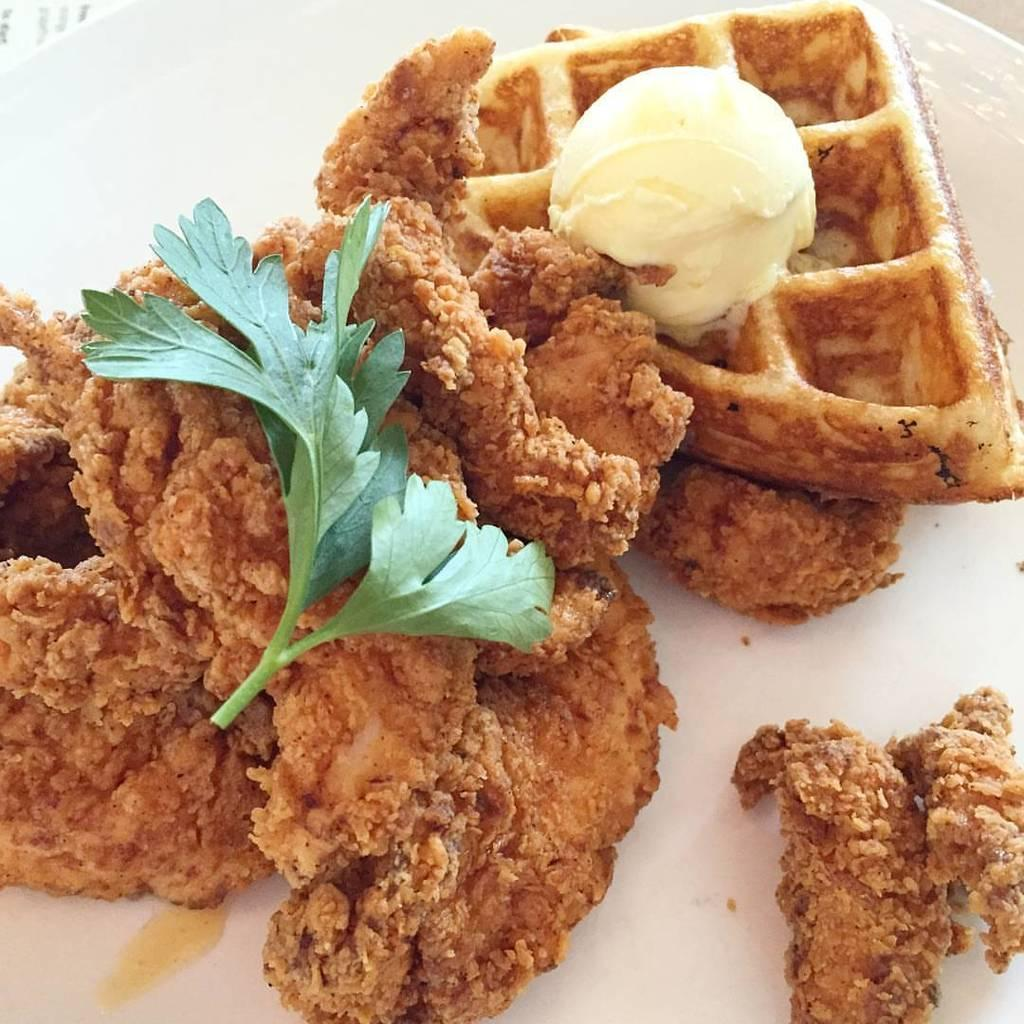What object is present in the image that typically holds food? There is a plate in the image that typically holds food. What can be found on the plate in the image? There is food on the plate in the image. What type of quartz can be seen in the image? There is no quartz present in the image. How many houses are visible in the image? There are no houses visible in the image. What type of meeting is taking place in the image? There is no meeting present in the image. 